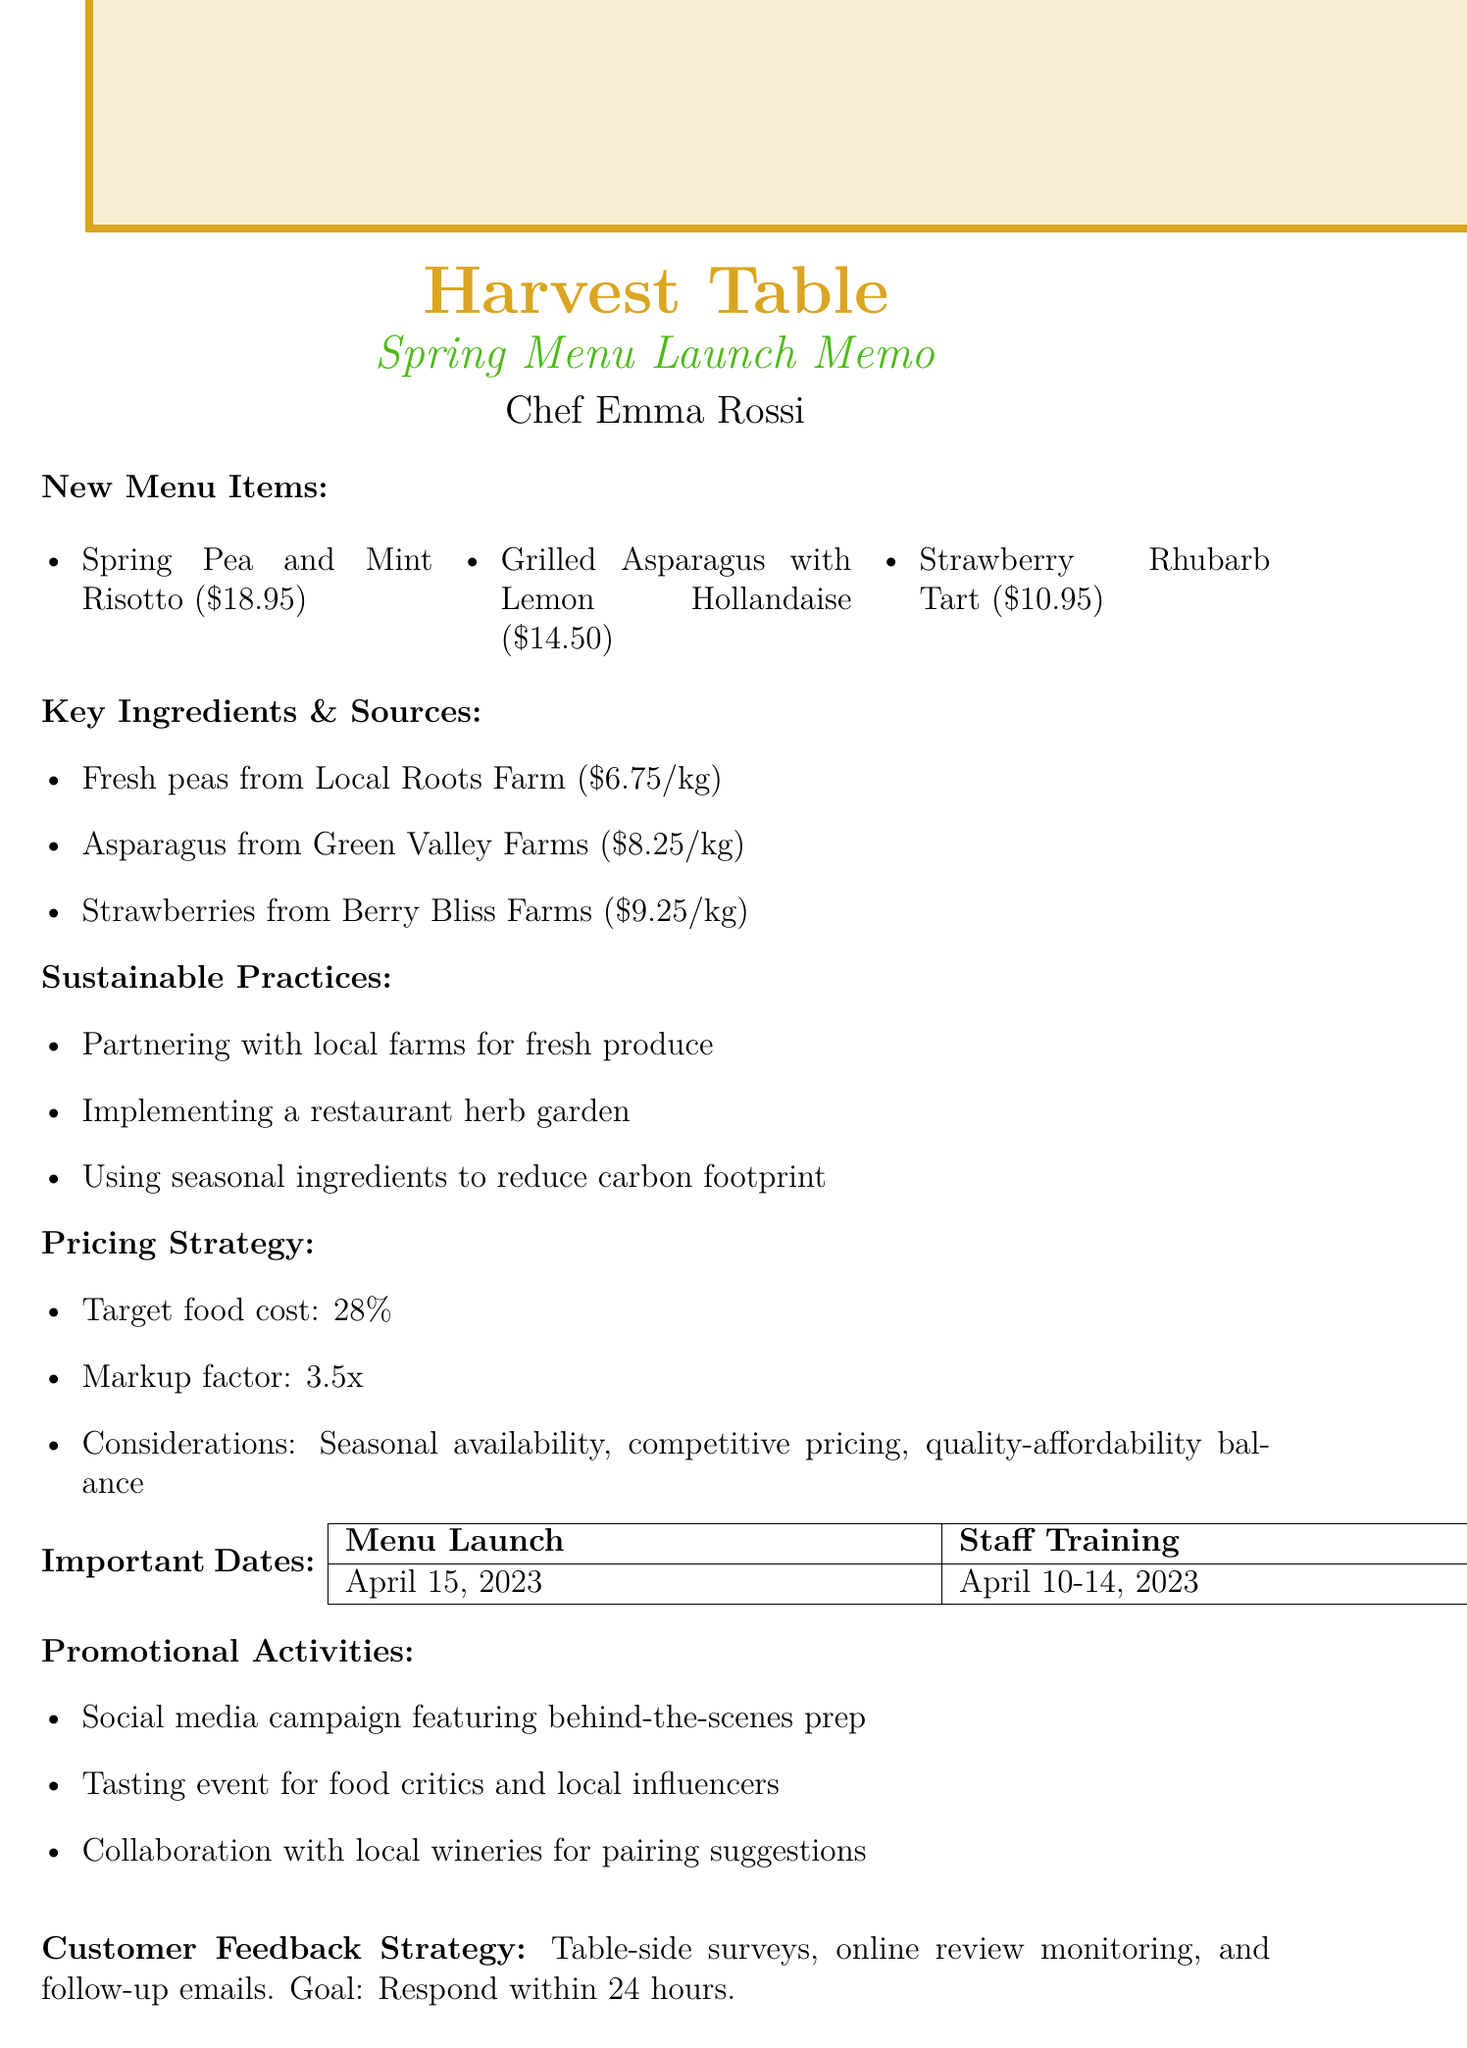What is the name of the restaurant? The document specifies that the restaurant is called "Harvest Table."
Answer: Harvest Table Who is the chef? The chef mentioned in the document is Emma Rossi.
Answer: Emma Rossi What is the selling price of the Strawberry Rhubarb Tart? The document states that the selling price for the Strawberry Rhubarb Tart is $10.95.
Answer: $10.95 What is the target food cost percentage? According to the pricing strategy in the document, the target food cost percentage is 28%.
Answer: 28% When is the menu launch date? The menu launch date mentioned in the document is April 15, 2023.
Answer: April 15, 2023 Which farm supplies fresh peas? The document indicates that fresh peas are from Local Roots Farm.
Answer: Local Roots Farm What are the promotional activities listed? There are multiple promotional activities mentioned in the document including a social media campaign, a tasting event, and collaboration with wineries.
Answer: Social media campaign, tasting event, collaboration with wineries What is the rationale behind the pricing strategy? The document outlines several considerations for the pricing strategy, such as seasonal availability and competitive pricing.
Answer: Seasonal availability, competitive pricing, quality-affordability balance What is one sustainable practice mentioned? One sustainable practice from the document is partnering with local farms for fresh produce.
Answer: Partnering with local farms for fresh produce 